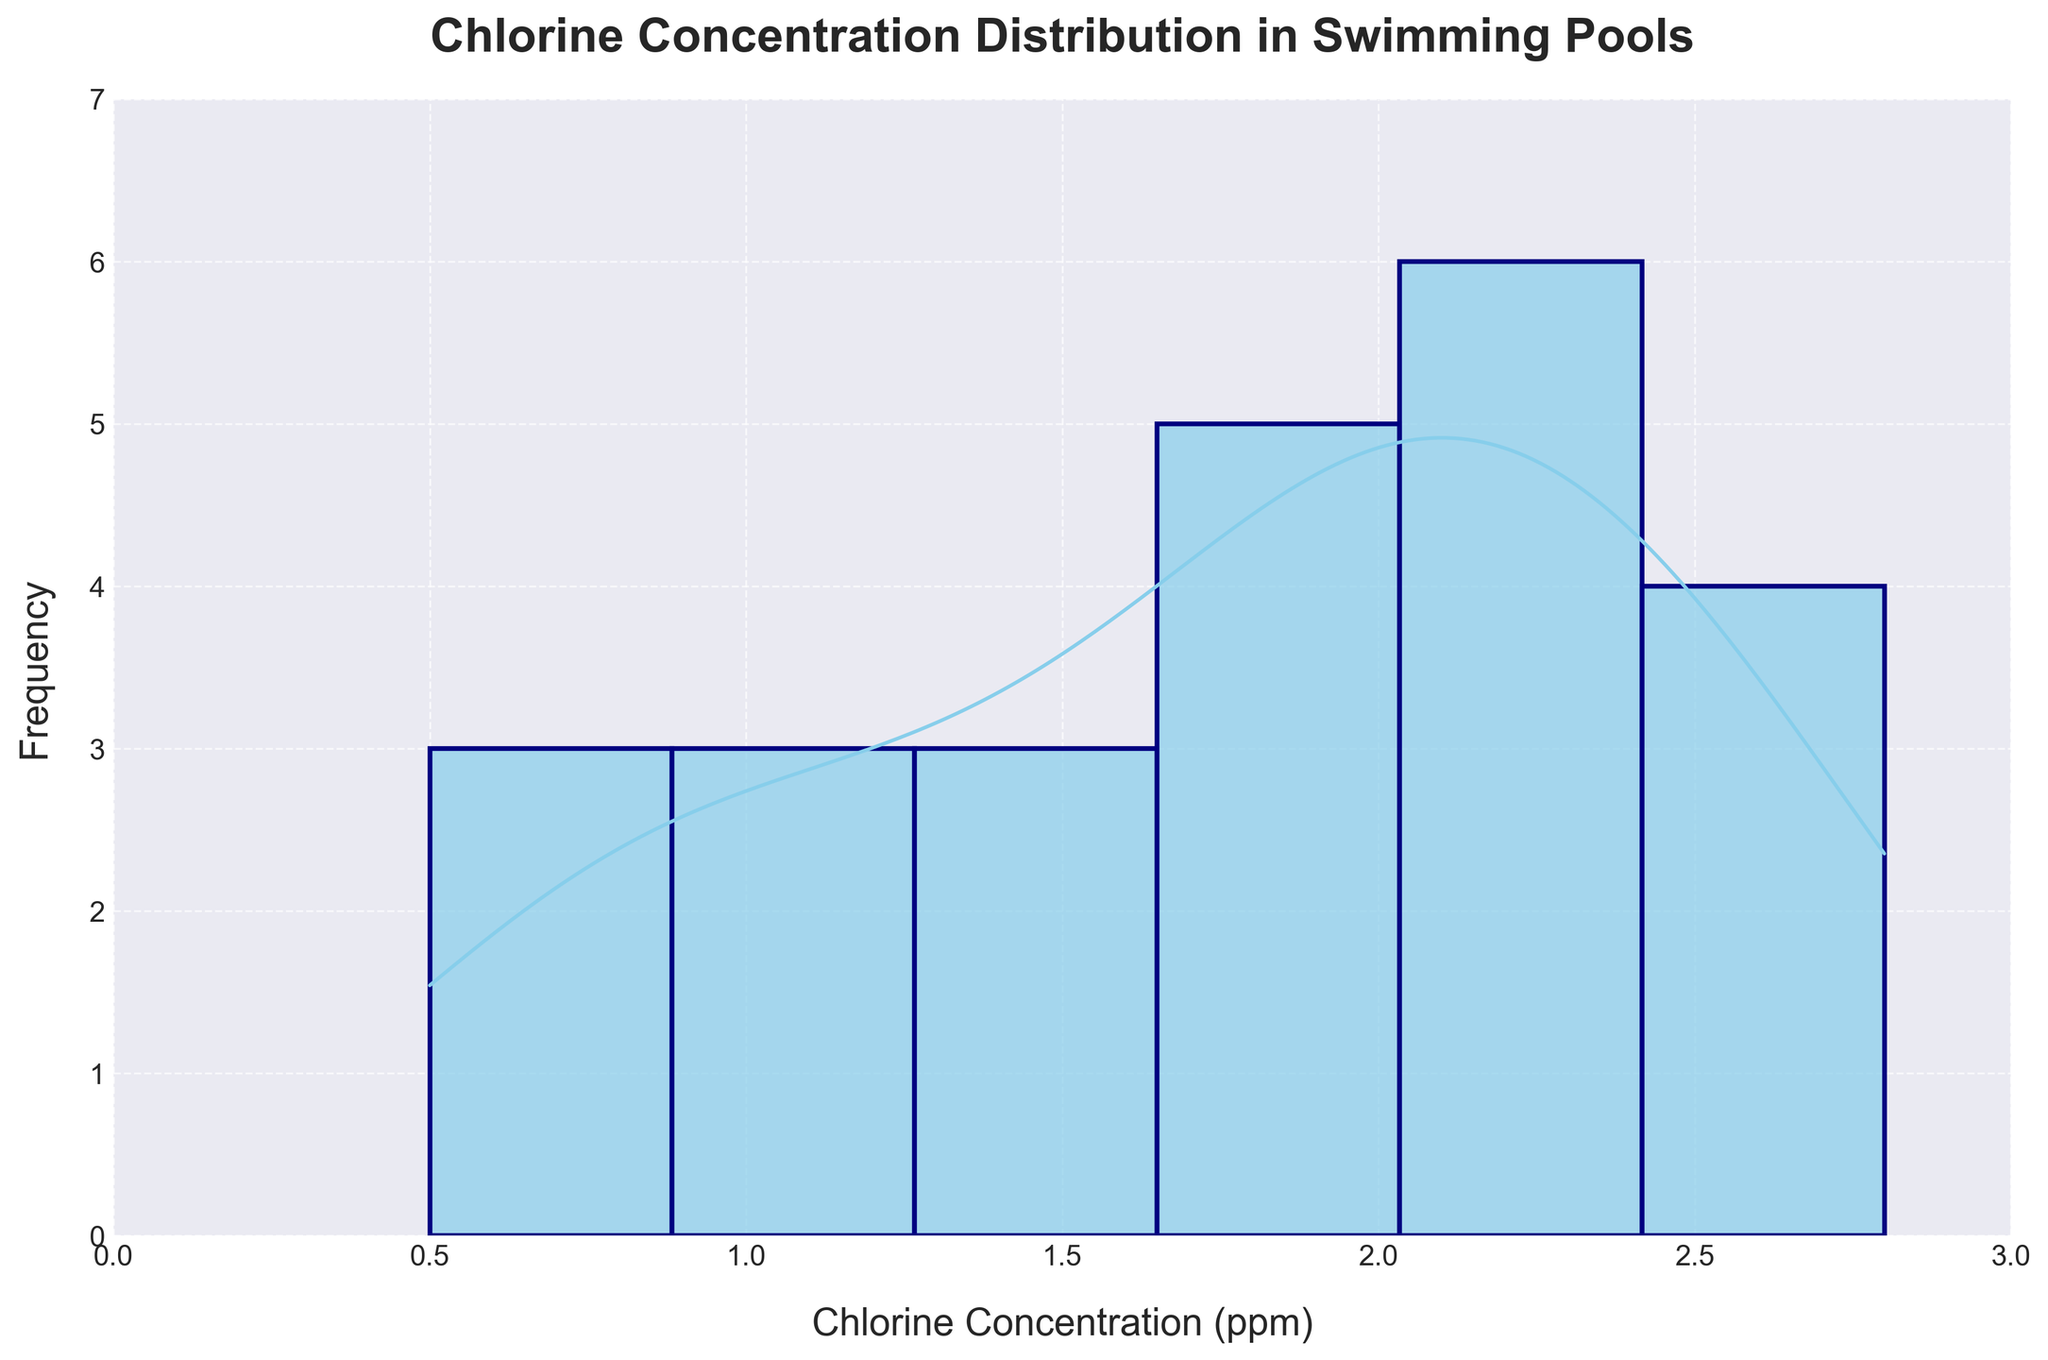What is the title of the histogram? The title is located at the top of the figure and reads, "Chlorine Concentration Distribution in Swimming Pools."
Answer: Chlorine Concentration Distribution in Swimming Pools What is the range of the x-axis? The x-axis represents the Chlorine Concentration (ppm) and ranges from 0 to 3 as indicated by the axis limits.
Answer: 0 to 3 What is the y-axis label? The y-axis label, which indicates what the y-axis measures, reads "Frequency."
Answer: Frequency How many peaks does the density curve show? Observing the density curve, it shows two peaks, indicating two modes in the distribution.
Answer: Two At what chlorine concentration does the first peak of the density curve occur? The first peak of the density curve occurs at a chlorine concentration around 1.0 ppm, as indicated by the highest point in this region along the x-axis.
Answer: Around 1.0 ppm What is the Chlorine Concentration value corresponding to the second peak on the density curve? The second peak on the density curve can be observed at approximately 2.5 ppm on the x-axis.
Answer: Approximately 2.5 ppm Which chlorine concentration has the highest frequency in the histogram? By comparing the histogram bars, the chlorine concentration of about 2.2 ppm has the highest frequency.
Answer: About 2.2 ppm How many bars are there approximately between chlorine concentrations of 0.5 ppm and 1.5 ppm? Count the histogram bars between the chlorine concentrations of 0.5 ppm and 1.5 ppm. There are approximately four bars within this range.
Answer: Approximately four Is the histogram roughly symmetric, skewed to the left, or skewed to the right? The histogram appears to have a larger frequency on the right, indicating it is skewed to the left.
Answer: Skewed to the left What can be inferred about the usage pattern of the swimming pool based on the histogram and density curve? The histogram and density curve suggest two peaks suggesting higher chlorine concentrations during certain times (e.g., early morning or late evening), likely indicating increased usage or maintenance activities during these periods, with lower concentrations when the pool is less used.
Answer: Higher usages likely during early morning and late evening 